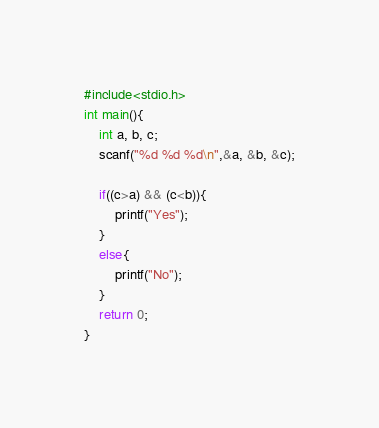<code> <loc_0><loc_0><loc_500><loc_500><_C_>#include<stdio.h>
int main(){
    int a, b, c;
    scanf("%d %d %d\n",&a, &b, &c);
    
    if((c>a) && (c<b)){
        printf("Yes");
    }
    else{
        printf("No");
    }
    return 0;
}
</code> 